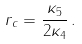Convert formula to latex. <formula><loc_0><loc_0><loc_500><loc_500>r _ { c } = \frac { \kappa _ { 5 } } { 2 \kappa _ { 4 } } \, .</formula> 